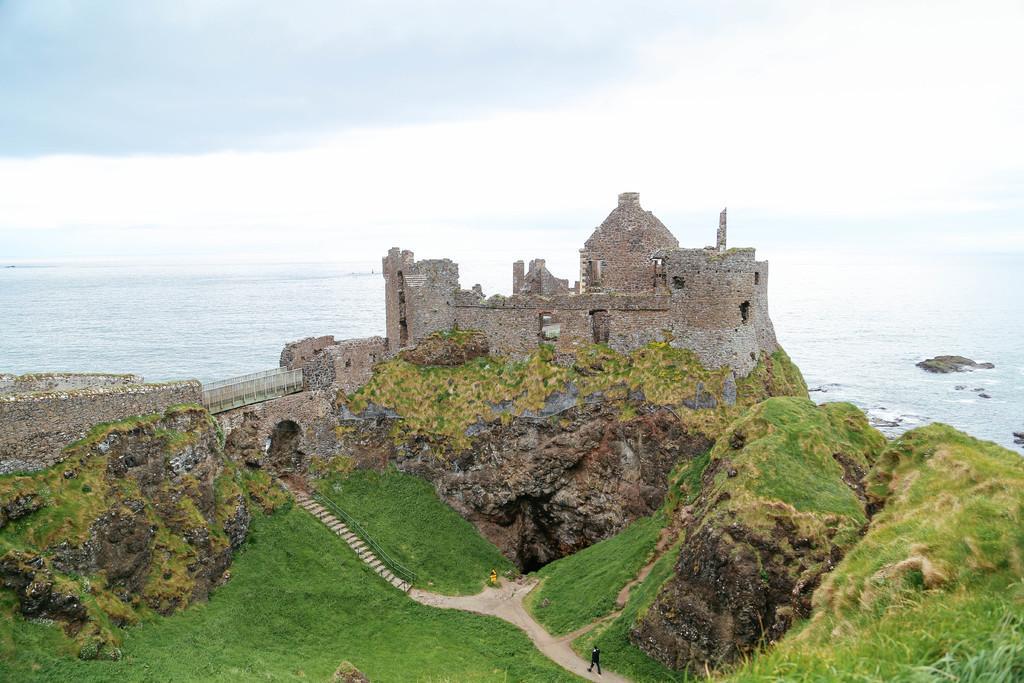How would you summarize this image in a sentence or two? In this image we can see grass, a man walking on the ground, a building, bridge, water and sky at the background. 